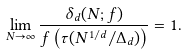<formula> <loc_0><loc_0><loc_500><loc_500>\lim _ { N \to \infty } \frac { \delta _ { d } ( N ; f ) } { f \left ( \tau ( N ^ { 1 / d } / \Delta _ { d } ) \right ) } = 1 .</formula> 